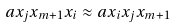<formula> <loc_0><loc_0><loc_500><loc_500>a x _ { j } x _ { m + 1 } x _ { i } \approx a x _ { i } x _ { j } x _ { m + 1 }</formula> 